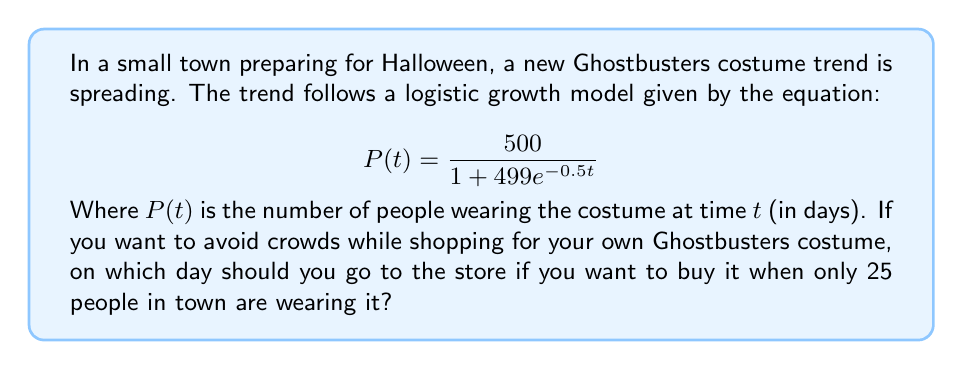Solve this math problem. To solve this problem, we need to follow these steps:

1) We want to find $t$ when $P(t) = 25$. So, we set up the equation:

   $$25 = \frac{500}{1 + 499e^{-0.5t}}$$

2) Multiply both sides by $(1 + 499e^{-0.5t})$:

   $$25(1 + 499e^{-0.5t}) = 500$$

3) Expand the left side:

   $$25 + 12475e^{-0.5t} = 500$$

4) Subtract 25 from both sides:

   $$12475e^{-0.5t} = 475$$

5) Divide both sides by 12475:

   $$e^{-0.5t} = \frac{475}{12475} = 0.0380761$$

6) Take the natural log of both sides:

   $$-0.5t = \ln(0.0380761)$$

7) Divide both sides by -0.5:

   $$t = \frac{\ln(0.0380761)}{-0.5} = 6.4726$$

8) Since we're dealing with days, we round up to the nearest whole number.
Answer: 7 days 